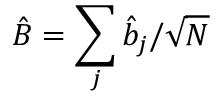<formula> <loc_0><loc_0><loc_500><loc_500>\hat { B } = \sum _ { j } \hat { b } _ { j } / \sqrt { N }</formula> 